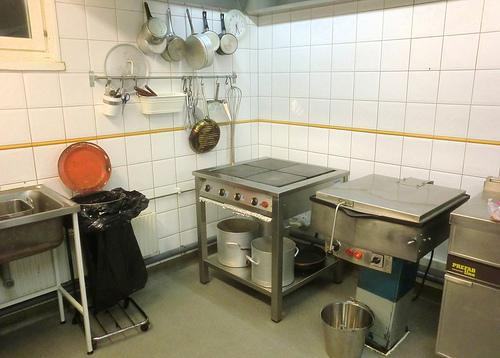Can you give a brief description of the wall and the items hanging from it? The wall has white square tiles, and it has pots, pans, a frying pan, a whisk, a scissor, and a white clock hanging on it. Please provide a description of the flooring and any objects placed on the floor in the image. The floor has a gray color and has a pail, a shiny silver bucket, and a large black trash can with a shiny black trash bag on it. There is also an empty bin on the floor. How would you describe the overall sentiment or mood of the image? The image has a functional and organized mood, showcasing a clean and well-equipped kitchen. What is the primary color of the kitchen appliances in the image? The primary color of the kitchen appliances is black. Which objects in the image interact or have a direct relationship with one another? The stove and the knobs have a direct relationship, as do the pots, pans, and their respective lids and handles. How many black knobs are there on the appliances in the image? There are 12 black knobs on the appliances in the image. What color are the majority of the knobs on the appliances in the picture? The majority of the knobs on the appliances are black. Can you identify the type of stove in the image and its main characteristics? It is an electronic powered stove with a large black surface and multiple knobs for controlling the settings. Are there any orange-colored objects in the image? If so, describe them. Yes, there are two orange-colored objects: a large round orange plate and an orange line on the white wall. List the objects in the image that serve a similar purpose or belong to the same category. Pots, pans, and frying pan; knobs on appliances; items hanging on the wall; objects on the floor (pail, bucket, trash can, and bin). 